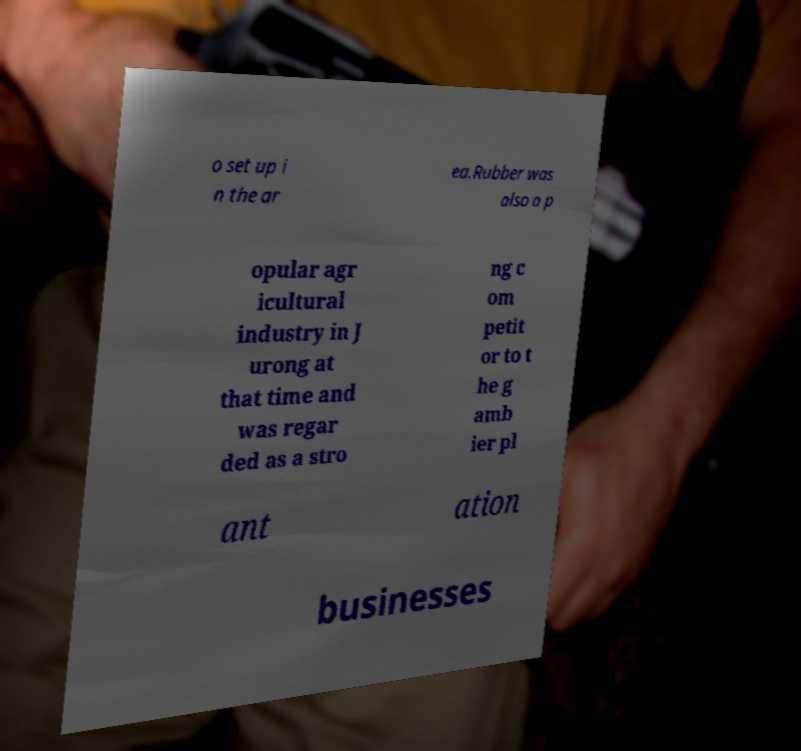Could you assist in decoding the text presented in this image and type it out clearly? o set up i n the ar ea.Rubber was also a p opular agr icultural industry in J urong at that time and was regar ded as a stro ng c om petit or to t he g amb ier pl ant ation businesses 